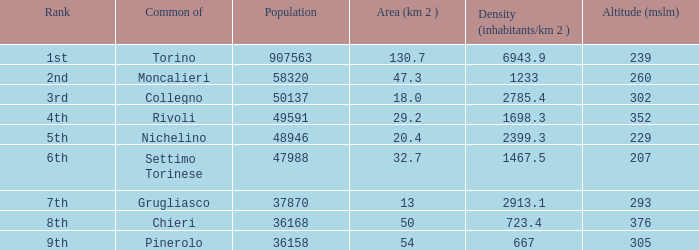The common of Chieri has what population density? 723.4. 